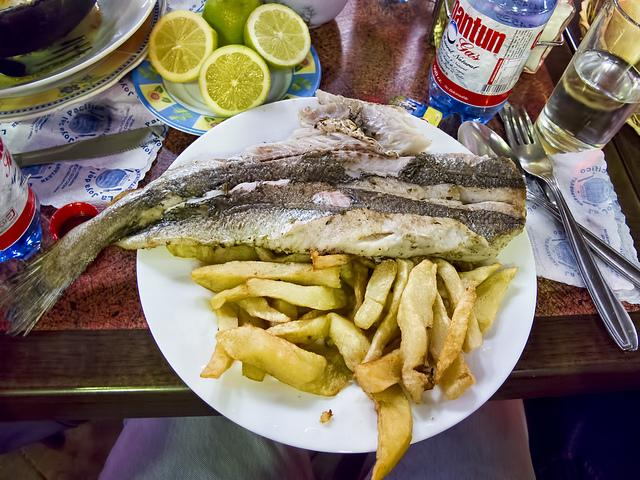What country's citizens are famous for eating this food combination?

Choices:
A) south africa
B) philippines
C) fiji
D) england england 